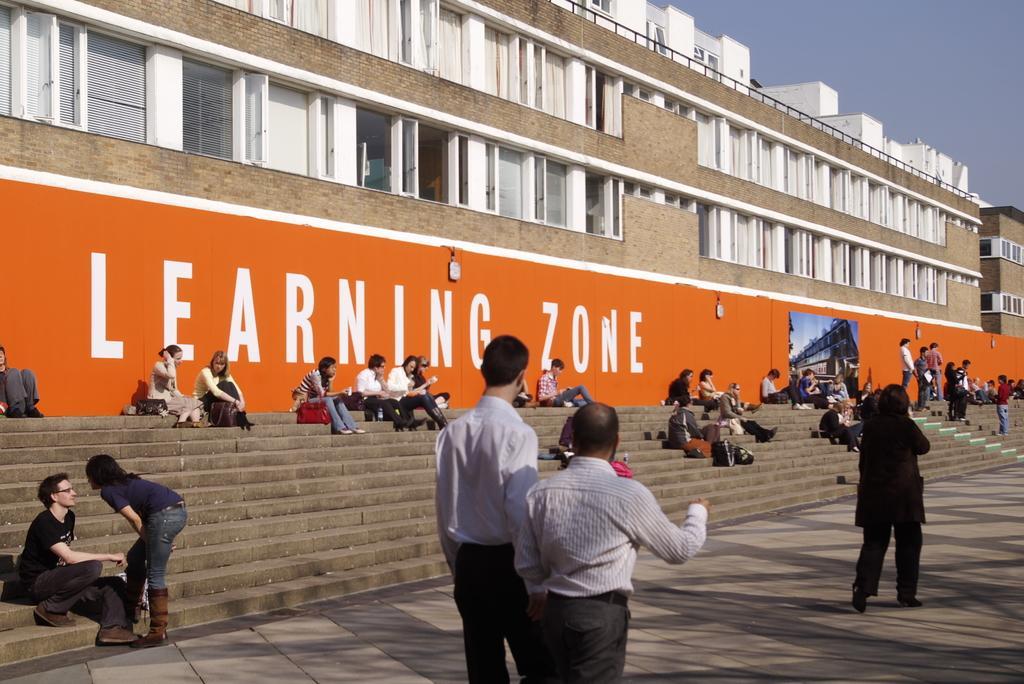In one or two sentences, can you explain what this image depicts? Here in this picture we can see buildings present all over there and we can also see windows on the buildings over there and in front of that we can see steps present, on which we can see people sitting over there and on the road we can see people walking and standing all over there. 